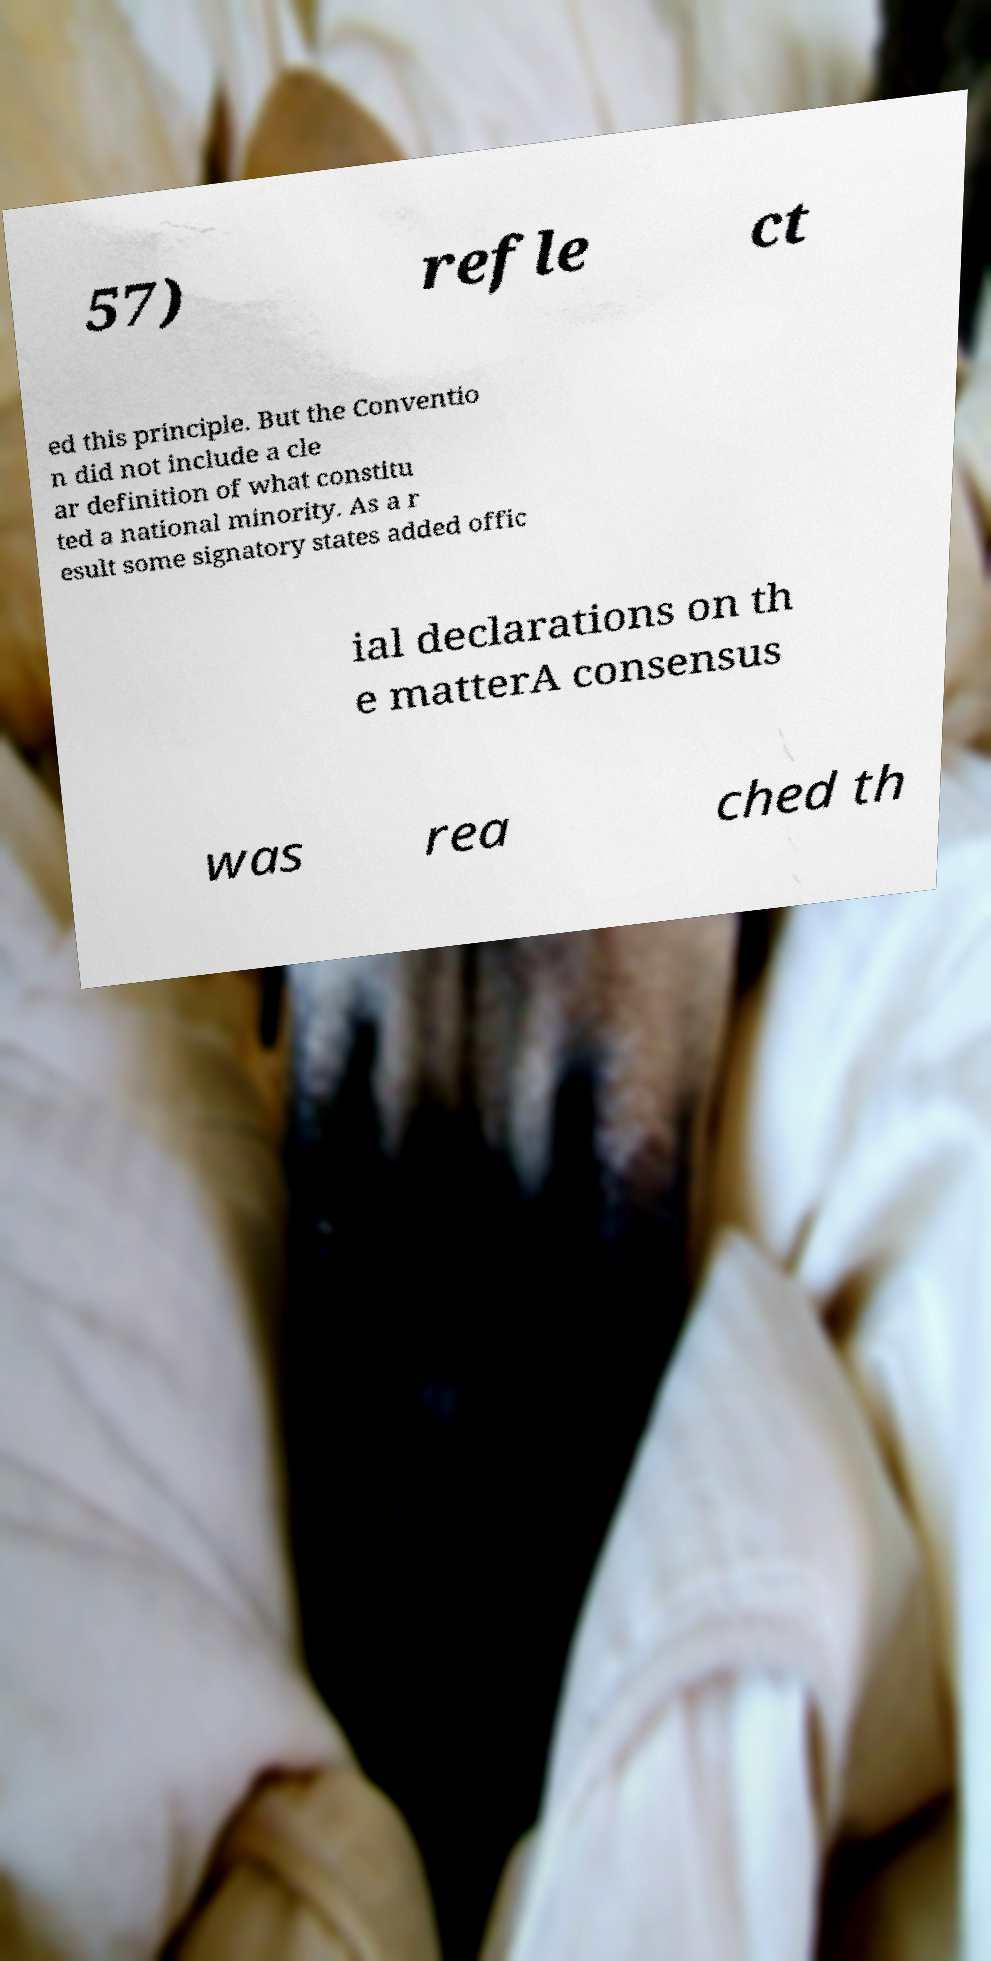Could you extract and type out the text from this image? 57) refle ct ed this principle. But the Conventio n did not include a cle ar definition of what constitu ted a national minority. As a r esult some signatory states added offic ial declarations on th e matterA consensus was rea ched th 